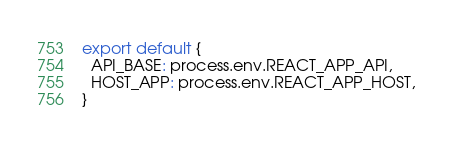Convert code to text. <code><loc_0><loc_0><loc_500><loc_500><_JavaScript_>export default {
  API_BASE: process.env.REACT_APP_API,
  HOST_APP: process.env.REACT_APP_HOST,
}</code> 